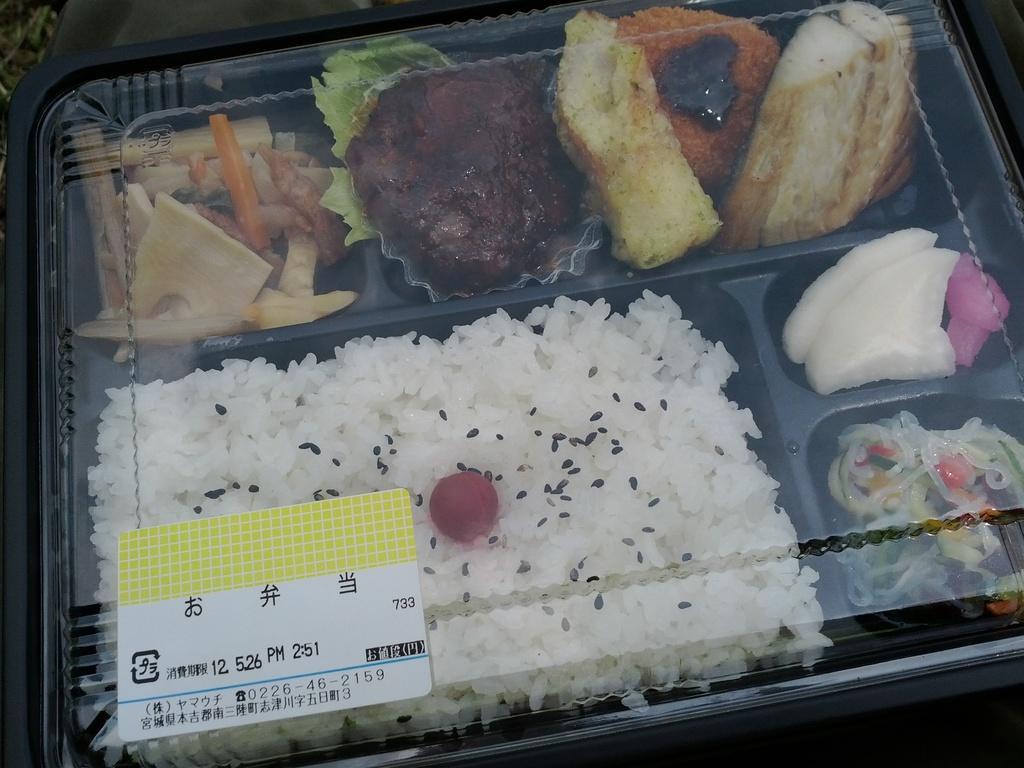Please provide a concise description of this image. In this image there is a box in which there is food. There are different kinds of dishes kept in the box. 